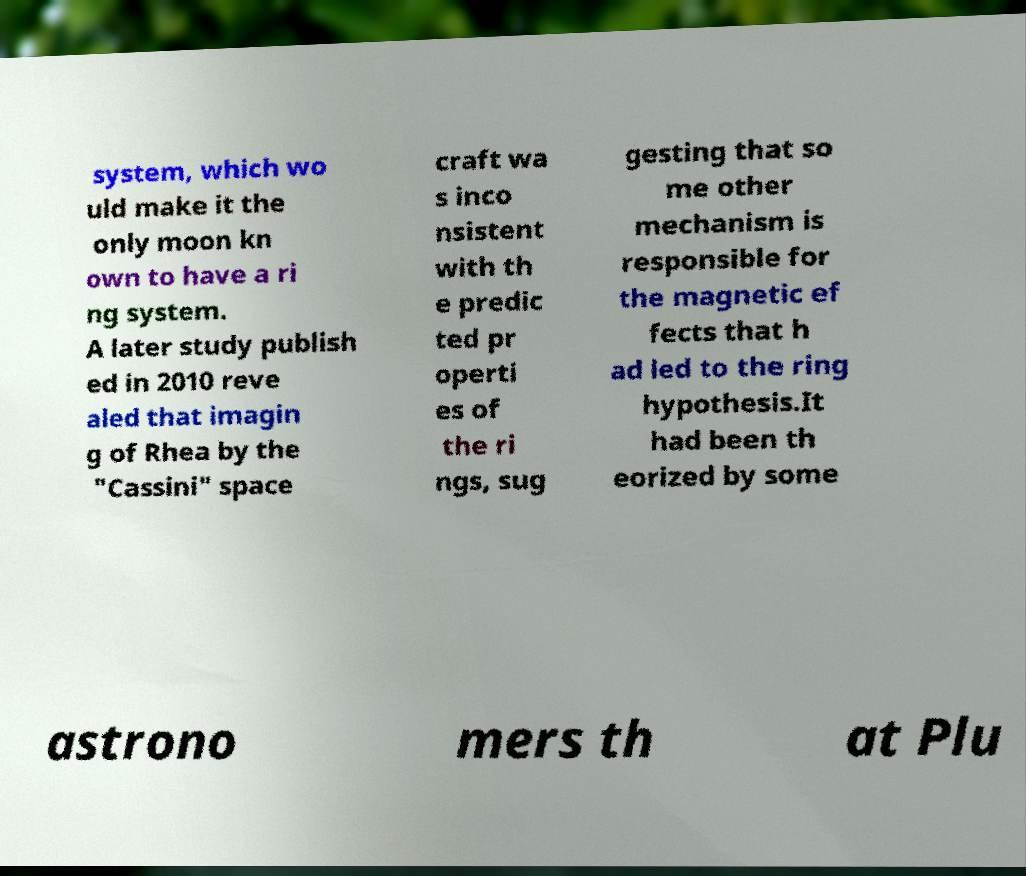I need the written content from this picture converted into text. Can you do that? system, which wo uld make it the only moon kn own to have a ri ng system. A later study publish ed in 2010 reve aled that imagin g of Rhea by the "Cassini" space craft wa s inco nsistent with th e predic ted pr operti es of the ri ngs, sug gesting that so me other mechanism is responsible for the magnetic ef fects that h ad led to the ring hypothesis.It had been th eorized by some astrono mers th at Plu 